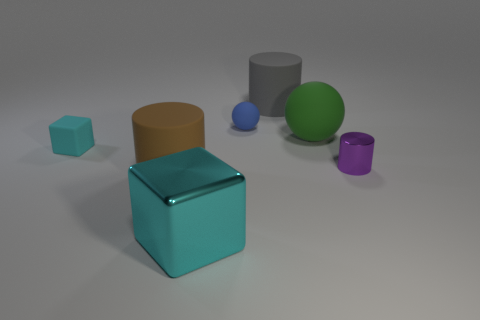Is the number of small blue things that are to the right of the small metal cylinder the same as the number of balls?
Provide a short and direct response. No. Is there a tiny cyan matte thing of the same shape as the cyan shiny thing?
Provide a succinct answer. Yes. There is a thing that is in front of the cyan rubber thing and right of the small blue object; what is its shape?
Offer a terse response. Cylinder. Is the large green object made of the same material as the cylinder that is right of the gray cylinder?
Your response must be concise. No. There is a tiny cyan matte object; are there any green spheres in front of it?
Offer a very short reply. No. How many things are either spheres or things to the left of the tiny purple cylinder?
Make the answer very short. 6. What is the color of the tiny thing that is on the right side of the big rubber sphere that is on the right side of the shiny cube?
Make the answer very short. Purple. What number of other objects are the same material as the purple cylinder?
Give a very brief answer. 1. What number of metal things are either cyan blocks or brown objects?
Provide a short and direct response. 1. What color is the shiny object that is the same shape as the small cyan rubber object?
Keep it short and to the point. Cyan. 